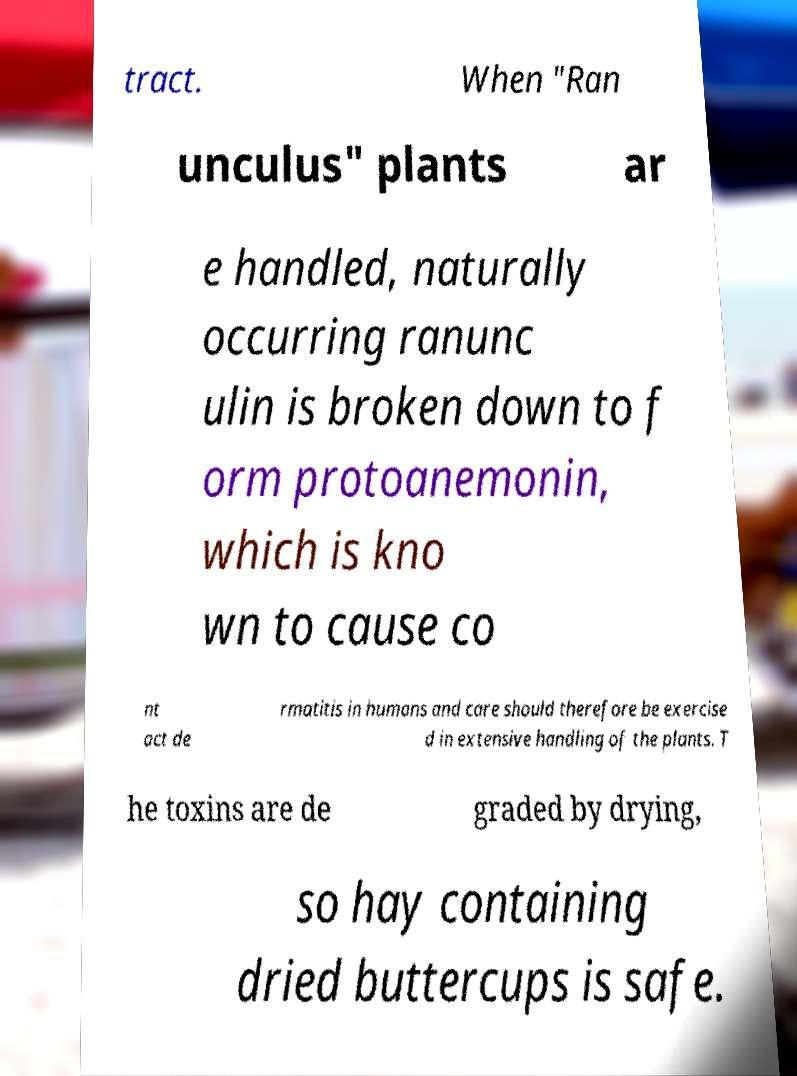I need the written content from this picture converted into text. Can you do that? tract. When "Ran unculus" plants ar e handled, naturally occurring ranunc ulin is broken down to f orm protoanemonin, which is kno wn to cause co nt act de rmatitis in humans and care should therefore be exercise d in extensive handling of the plants. T he toxins are de graded by drying, so hay containing dried buttercups is safe. 